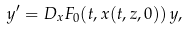Convert formula to latex. <formula><loc_0><loc_0><loc_500><loc_500>y ^ { \prime } = D _ { x } F _ { 0 } ( t , x ( t , z , 0 ) ) \, y ,</formula> 